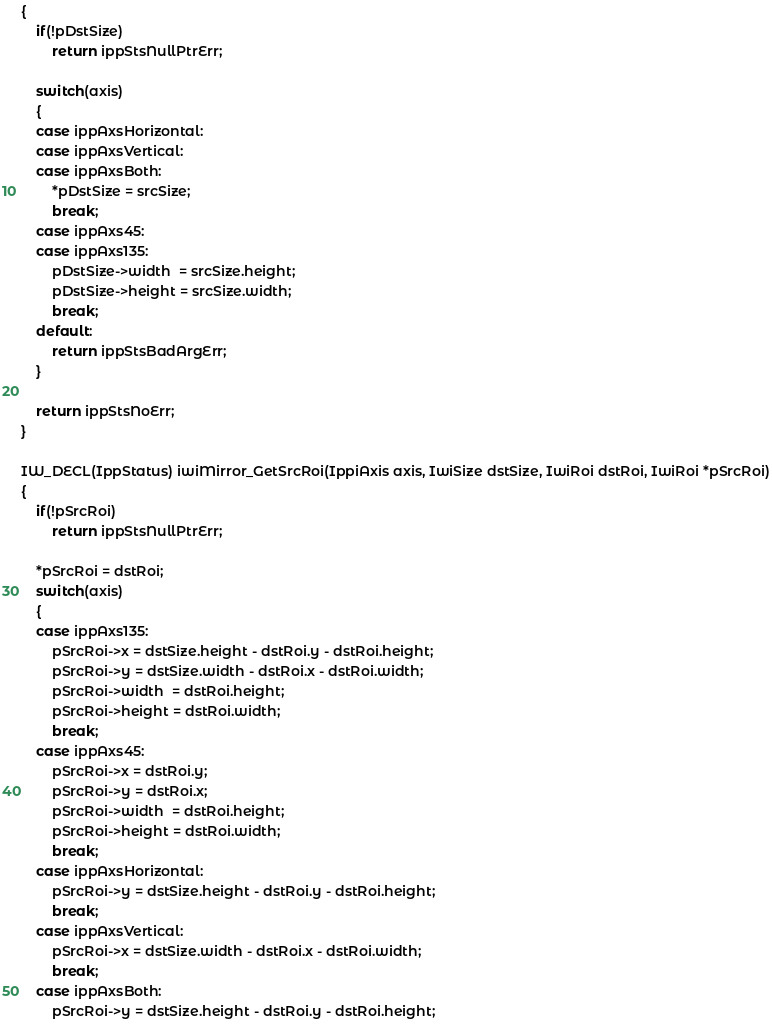<code> <loc_0><loc_0><loc_500><loc_500><_C_>{
    if(!pDstSize)
        return ippStsNullPtrErr;

    switch(axis)
    {
    case ippAxsHorizontal:
    case ippAxsVertical:
    case ippAxsBoth:
        *pDstSize = srcSize;
        break;
    case ippAxs45:
    case ippAxs135:
        pDstSize->width  = srcSize.height;
        pDstSize->height = srcSize.width;
        break;
    default:
        return ippStsBadArgErr;
    }

    return ippStsNoErr;
}

IW_DECL(IppStatus) iwiMirror_GetSrcRoi(IppiAxis axis, IwiSize dstSize, IwiRoi dstRoi, IwiRoi *pSrcRoi)
{
    if(!pSrcRoi)
        return ippStsNullPtrErr;

    *pSrcRoi = dstRoi;
    switch(axis)
    {
    case ippAxs135:
        pSrcRoi->x = dstSize.height - dstRoi.y - dstRoi.height;
        pSrcRoi->y = dstSize.width - dstRoi.x - dstRoi.width;
        pSrcRoi->width  = dstRoi.height;
        pSrcRoi->height = dstRoi.width;
        break;
    case ippAxs45:
        pSrcRoi->x = dstRoi.y;
        pSrcRoi->y = dstRoi.x;
        pSrcRoi->width  = dstRoi.height;
        pSrcRoi->height = dstRoi.width;
        break;
    case ippAxsHorizontal:
        pSrcRoi->y = dstSize.height - dstRoi.y - dstRoi.height;
        break;
    case ippAxsVertical:
        pSrcRoi->x = dstSize.width - dstRoi.x - dstRoi.width;
        break;
    case ippAxsBoth:
        pSrcRoi->y = dstSize.height - dstRoi.y - dstRoi.height;</code> 